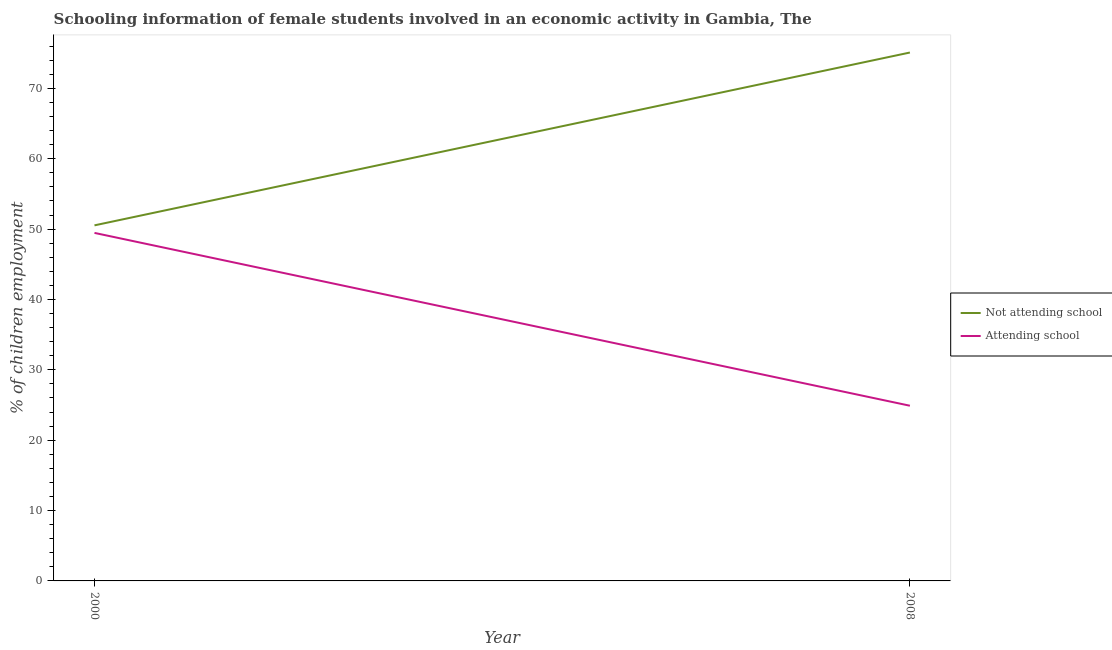Is the number of lines equal to the number of legend labels?
Keep it short and to the point. Yes. What is the percentage of employed females who are attending school in 2000?
Ensure brevity in your answer.  49.46. Across all years, what is the maximum percentage of employed females who are not attending school?
Provide a short and direct response. 75.1. Across all years, what is the minimum percentage of employed females who are attending school?
Offer a very short reply. 24.9. In which year was the percentage of employed females who are not attending school maximum?
Your response must be concise. 2008. What is the total percentage of employed females who are not attending school in the graph?
Provide a short and direct response. 125.64. What is the difference between the percentage of employed females who are attending school in 2000 and that in 2008?
Ensure brevity in your answer.  24.56. What is the difference between the percentage of employed females who are not attending school in 2008 and the percentage of employed females who are attending school in 2000?
Provide a short and direct response. 25.64. What is the average percentage of employed females who are not attending school per year?
Your response must be concise. 62.82. In the year 2008, what is the difference between the percentage of employed females who are attending school and percentage of employed females who are not attending school?
Your response must be concise. -50.2. In how many years, is the percentage of employed females who are not attending school greater than 22 %?
Offer a very short reply. 2. What is the ratio of the percentage of employed females who are not attending school in 2000 to that in 2008?
Offer a terse response. 0.67. In how many years, is the percentage of employed females who are attending school greater than the average percentage of employed females who are attending school taken over all years?
Make the answer very short. 1. Does the percentage of employed females who are not attending school monotonically increase over the years?
Offer a terse response. Yes. Is the percentage of employed females who are attending school strictly less than the percentage of employed females who are not attending school over the years?
Make the answer very short. Yes. How many lines are there?
Your answer should be very brief. 2. How many years are there in the graph?
Offer a terse response. 2. What is the difference between two consecutive major ticks on the Y-axis?
Make the answer very short. 10. Does the graph contain grids?
Make the answer very short. No. What is the title of the graph?
Ensure brevity in your answer.  Schooling information of female students involved in an economic activity in Gambia, The. What is the label or title of the Y-axis?
Give a very brief answer. % of children employment. What is the % of children employment in Not attending school in 2000?
Offer a very short reply. 50.54. What is the % of children employment of Attending school in 2000?
Give a very brief answer. 49.46. What is the % of children employment of Not attending school in 2008?
Offer a very short reply. 75.1. What is the % of children employment of Attending school in 2008?
Offer a very short reply. 24.9. Across all years, what is the maximum % of children employment of Not attending school?
Your answer should be very brief. 75.1. Across all years, what is the maximum % of children employment of Attending school?
Provide a succinct answer. 49.46. Across all years, what is the minimum % of children employment in Not attending school?
Offer a very short reply. 50.54. Across all years, what is the minimum % of children employment of Attending school?
Offer a terse response. 24.9. What is the total % of children employment of Not attending school in the graph?
Offer a very short reply. 125.64. What is the total % of children employment in Attending school in the graph?
Keep it short and to the point. 74.36. What is the difference between the % of children employment in Not attending school in 2000 and that in 2008?
Make the answer very short. -24.56. What is the difference between the % of children employment in Attending school in 2000 and that in 2008?
Provide a succinct answer. 24.56. What is the difference between the % of children employment in Not attending school in 2000 and the % of children employment in Attending school in 2008?
Ensure brevity in your answer.  25.64. What is the average % of children employment in Not attending school per year?
Your answer should be very brief. 62.82. What is the average % of children employment in Attending school per year?
Provide a succinct answer. 37.18. In the year 2000, what is the difference between the % of children employment in Not attending school and % of children employment in Attending school?
Offer a terse response. 1.07. In the year 2008, what is the difference between the % of children employment in Not attending school and % of children employment in Attending school?
Keep it short and to the point. 50.2. What is the ratio of the % of children employment of Not attending school in 2000 to that in 2008?
Make the answer very short. 0.67. What is the ratio of the % of children employment in Attending school in 2000 to that in 2008?
Your answer should be very brief. 1.99. What is the difference between the highest and the second highest % of children employment of Not attending school?
Your response must be concise. 24.56. What is the difference between the highest and the second highest % of children employment of Attending school?
Keep it short and to the point. 24.56. What is the difference between the highest and the lowest % of children employment of Not attending school?
Ensure brevity in your answer.  24.56. What is the difference between the highest and the lowest % of children employment in Attending school?
Offer a very short reply. 24.56. 